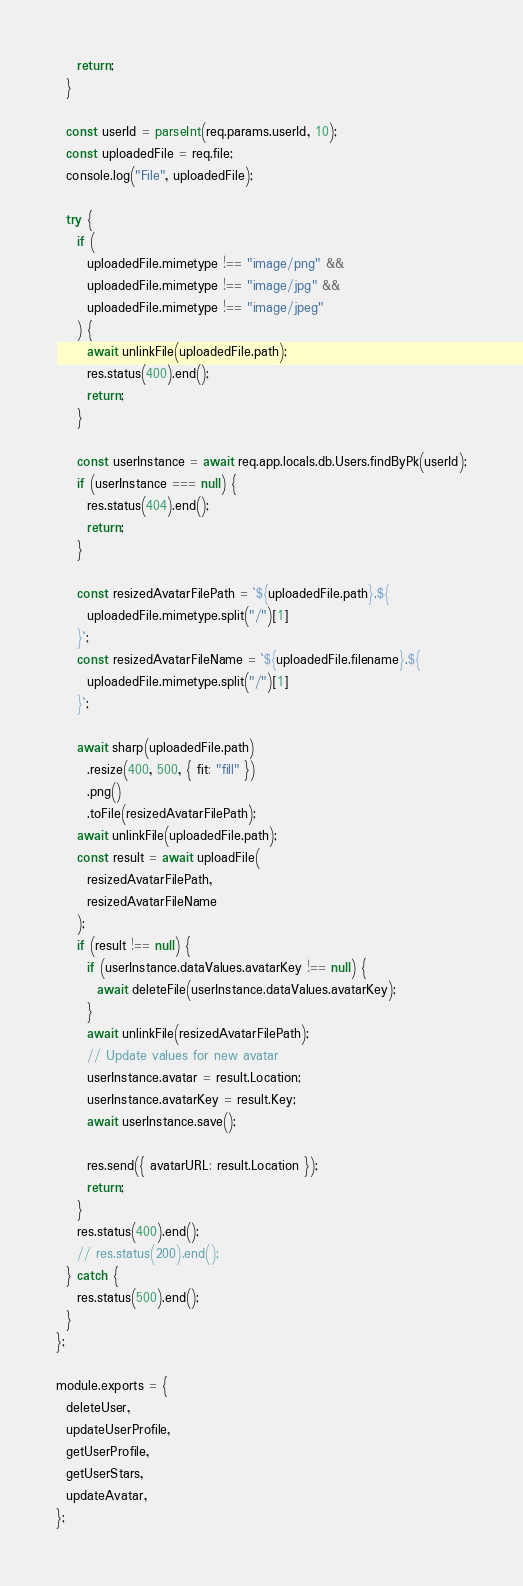<code> <loc_0><loc_0><loc_500><loc_500><_JavaScript_>    return;
  }

  const userId = parseInt(req.params.userId, 10);
  const uploadedFile = req.file;
  console.log("File", uploadedFile);

  try {
    if (
      uploadedFile.mimetype !== "image/png" &&
      uploadedFile.mimetype !== "image/jpg" &&
      uploadedFile.mimetype !== "image/jpeg"
    ) {
      await unlinkFile(uploadedFile.path);
      res.status(400).end();
      return;
    }

    const userInstance = await req.app.locals.db.Users.findByPk(userId);
    if (userInstance === null) {
      res.status(404).end();
      return;
    }

    const resizedAvatarFilePath = `${uploadedFile.path}.${
      uploadedFile.mimetype.split("/")[1]
    }`;
    const resizedAvatarFileName = `${uploadedFile.filename}.${
      uploadedFile.mimetype.split("/")[1]
    }`;

    await sharp(uploadedFile.path)
      .resize(400, 500, { fit: "fill" })
      .png()
      .toFile(resizedAvatarFilePath);
    await unlinkFile(uploadedFile.path);
    const result = await uploadFile(
      resizedAvatarFilePath,
      resizedAvatarFileName
    );
    if (result !== null) {
      if (userInstance.dataValues.avatarKey !== null) {
        await deleteFile(userInstance.dataValues.avatarKey);
      }
      await unlinkFile(resizedAvatarFilePath);
      // Update values for new avatar
      userInstance.avatar = result.Location;
      userInstance.avatarKey = result.Key;
      await userInstance.save();

      res.send({ avatarURL: result.Location });
      return;
    }
    res.status(400).end();
    // res.status(200).end();
  } catch {
    res.status(500).end();
  }
};

module.exports = {
  deleteUser,
  updateUserProfile,
  getUserProfile,
  getUserStars,
  updateAvatar,
};
</code> 